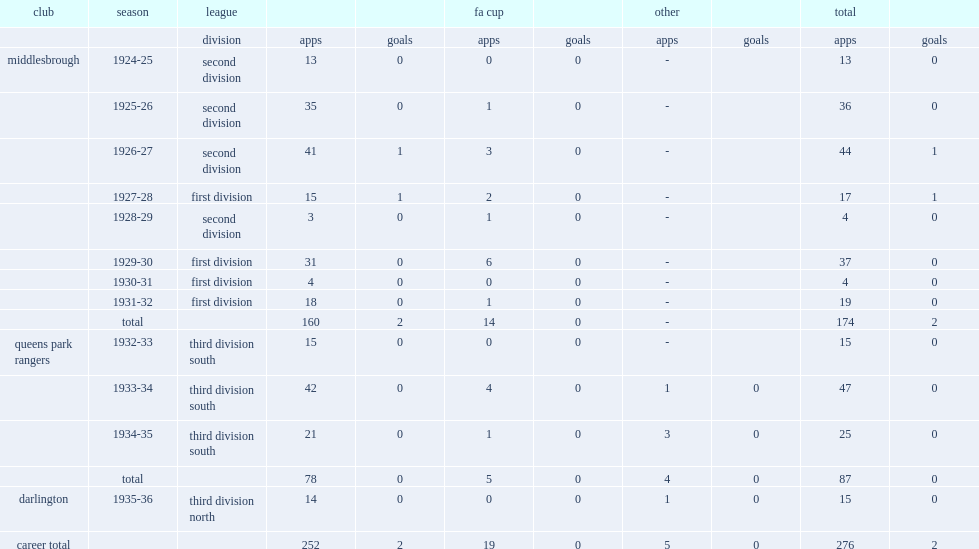How many appearances did don ashman make in the football league playing for middlesbrough, queens park rangers and darlington in the 1920s and 1930s? 252.0. 